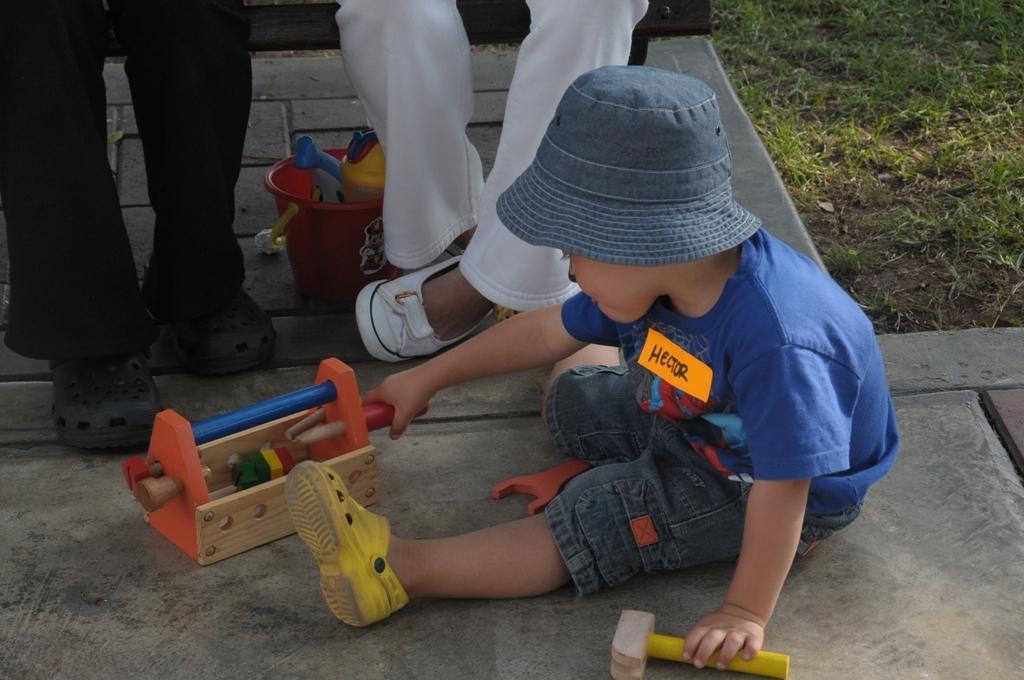Could you give a brief overview of what you see in this image? In this image, I can see a kid sitting on the floor and playing with toys. I can see two people sitting on the bench. On the right side of the image, there is grass. Under the bench, I can see a bucket with toys. 